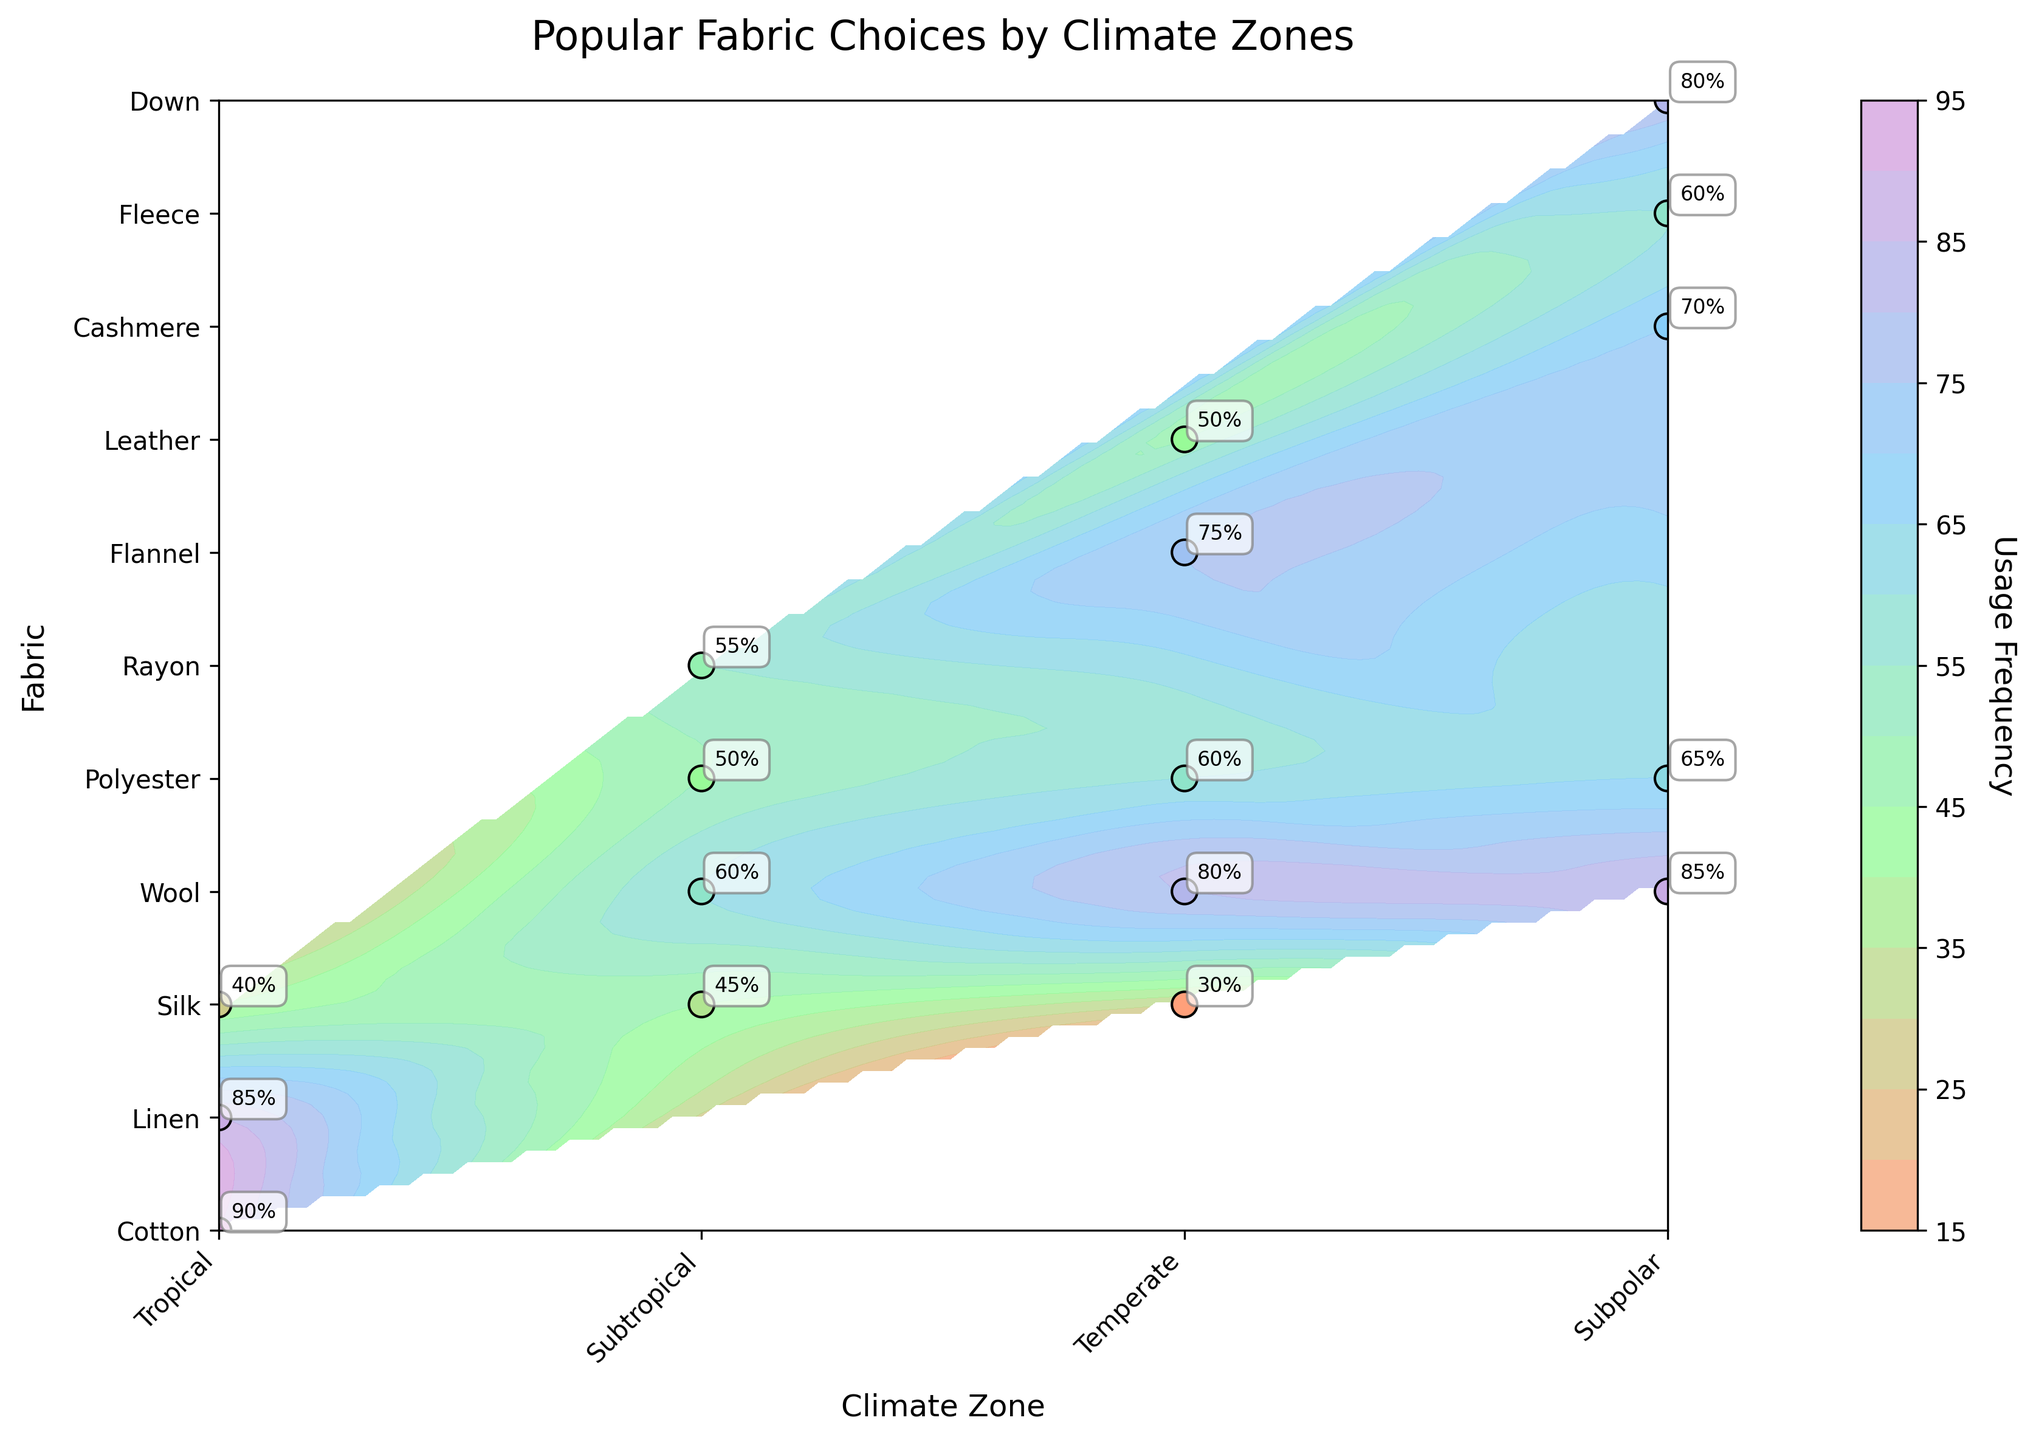What is the title of the figure? The title of the figure can be found at the top of the plot. It reads "Popular Fabric Choices by Climate Zones".
Answer: Popular Fabric Choices by Climate Zones What axis labels are on the plot? The x-axis label is "Climate Zone" and the y-axis label is "Fabric". These are located along the horizontal and vertical axes, respectively.
Answer: Climate Zone and Fabric Which fabric has the highest usage frequency in the Temperate zone? Observing the labels on the plot along with the usage frequency annotations, Wool has the highest usage frequency in the Temperate climate zone with an 80% usage frequency.
Answer: Wool What is the usage frequency of Flannel in the Temperate zone? Locate Flannel on the y-axis and Temperate on the x-axis. Find the label annotation where these two intersect. The usage frequency of Flannel in the Temperate zone is 75%.
Answer: 75% Compare the usage frequency of Silk in the Tropical, Subtropical, and Temperate zones. Which zone has the lowest usage frequency for Silk? Look at Silk in each climate zone and compare the usage frequencies labeled: Tropical (40%), Subtropical (45%), Temperate (30%). The Temperate zone has the lowest usage frequency for Silk.
Answer: Temperate How many fabrics are used in the Subpolar zone based on the plot? Count the number of unique fabric labels associated with the Subpolar zone. These are: Cashmere, Wool, Polyester, Fleece, and Down. There are 5 unique fabrics used in the Subpolar zone.
Answer: 5 In which climate zone is Wool the most popular fabric? Find Wool on the y-axis and compare its usage frequencies in different climate zones. Wool has the highest usage frequency in the Subpolar zone with 85%.
Answer: Subpolar What is common about the top 2 fabrics in the Tropical zone in terms of usage frequency? Identify the top 2 fabrics in the Tropical zone, which are Cotton (90%) and Linen (85%). Both fabrics are breathable and lightweight, suitable for tropical climates.
Answer: Breathable and lightweight Which climate zone shows the highest usage frequency for Down? Locate Down on the y-axis and follow it to the Subpolar zone. The highest usage frequency for Down is 80% in the Subpolar zone.
Answer: Subpolar Calculate the average usage frequency of Polyester across all climate zones. Add the usage frequencies of Polyester in each climate zone (50 in Subtropical, 60 in Temperate, 65 in Subpolar), then divide by 3. The average is (50 + 60 + 65)/3 = 175/3 ≈ 58.33.
Answer: 58.33 